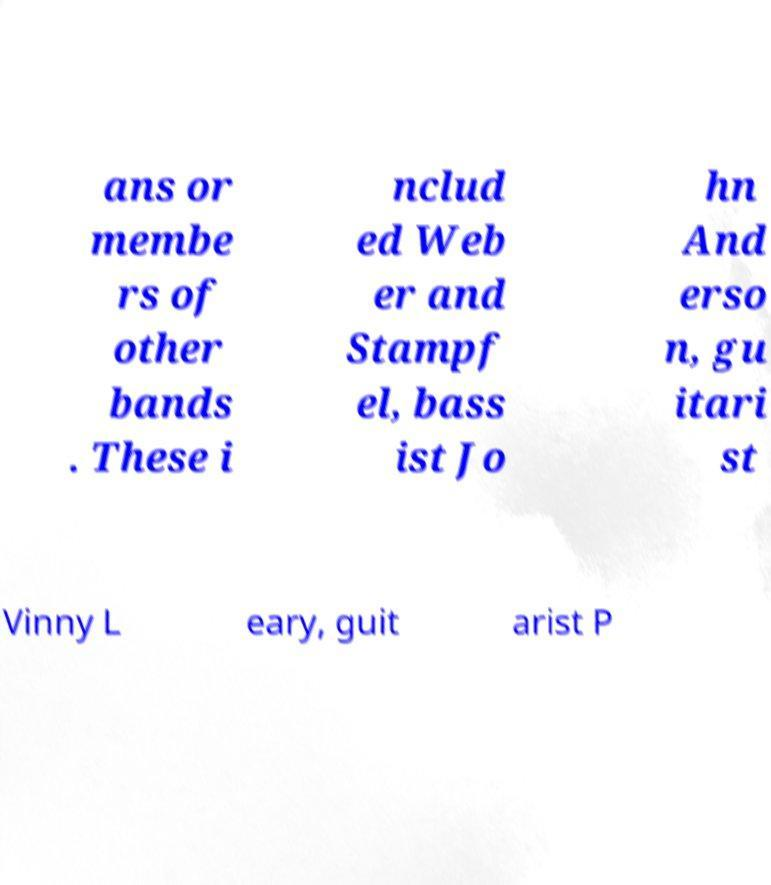Can you read and provide the text displayed in the image?This photo seems to have some interesting text. Can you extract and type it out for me? ans or membe rs of other bands . These i nclud ed Web er and Stampf el, bass ist Jo hn And erso n, gu itari st Vinny L eary, guit arist P 